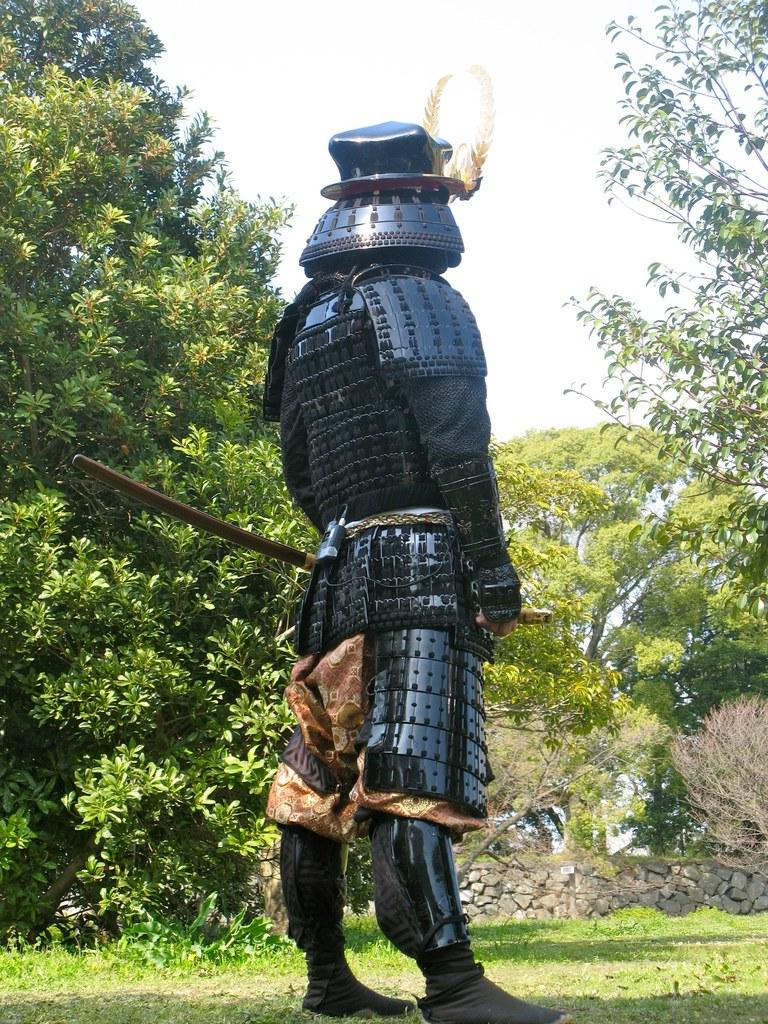What is the person in the image wearing? The person is wearing armor in the image. What weapon is the person holding? The person is holding a sword in the image. What type of natural environment can be seen in the image? There are trees in the middle of the image. What is visible at the top of the image? The sky is visible at the top of the image. Where is the dock located in the image? There is no dock present in the image. 